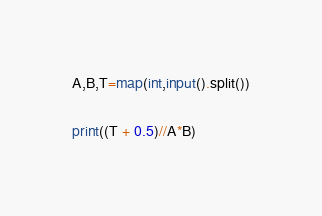<code> <loc_0><loc_0><loc_500><loc_500><_Python_>A,B,T=map(int,input().split())

print((T + 0.5)//A*B)</code> 